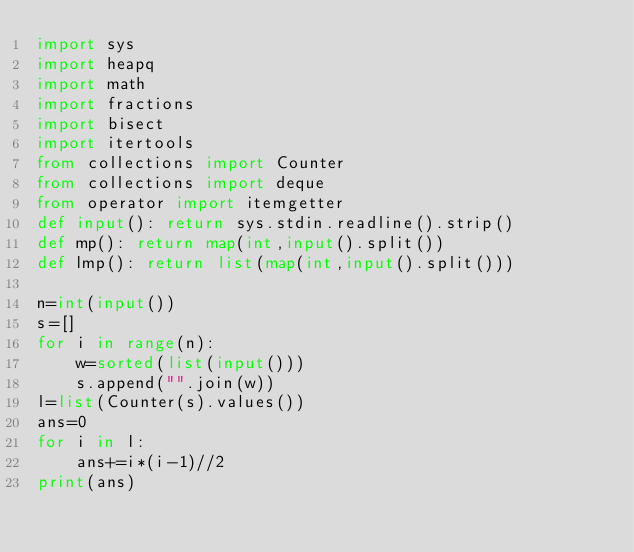<code> <loc_0><loc_0><loc_500><loc_500><_Python_>import sys
import heapq
import math
import fractions
import bisect
import itertools
from collections import Counter
from collections import deque
from operator import itemgetter
def input(): return sys.stdin.readline().strip()
def mp(): return map(int,input().split())
def lmp(): return list(map(int,input().split()))

n=int(input())
s=[]
for i in range(n):
    w=sorted(list(input()))
    s.append("".join(w))
l=list(Counter(s).values())
ans=0
for i in l:
    ans+=i*(i-1)//2
print(ans)</code> 